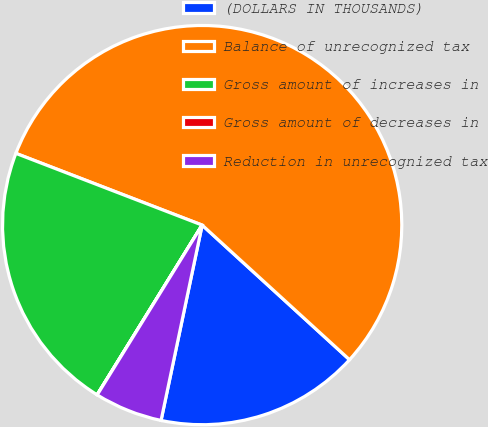Convert chart to OTSL. <chart><loc_0><loc_0><loc_500><loc_500><pie_chart><fcel>(DOLLARS IN THOUSANDS)<fcel>Balance of unrecognized tax<fcel>Gross amount of increases in<fcel>Gross amount of decreases in<fcel>Reduction in unrecognized tax<nl><fcel>16.52%<fcel>55.93%<fcel>22.03%<fcel>0.01%<fcel>5.51%<nl></chart> 